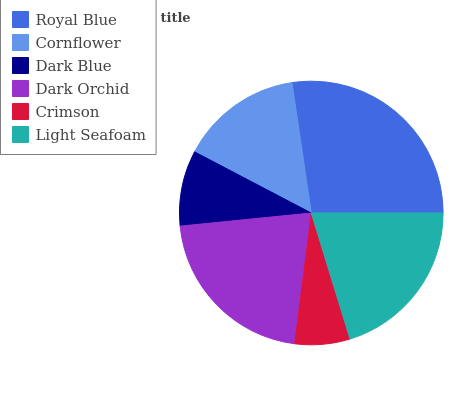Is Crimson the minimum?
Answer yes or no. Yes. Is Royal Blue the maximum?
Answer yes or no. Yes. Is Cornflower the minimum?
Answer yes or no. No. Is Cornflower the maximum?
Answer yes or no. No. Is Royal Blue greater than Cornflower?
Answer yes or no. Yes. Is Cornflower less than Royal Blue?
Answer yes or no. Yes. Is Cornflower greater than Royal Blue?
Answer yes or no. No. Is Royal Blue less than Cornflower?
Answer yes or no. No. Is Light Seafoam the high median?
Answer yes or no. Yes. Is Cornflower the low median?
Answer yes or no. Yes. Is Crimson the high median?
Answer yes or no. No. Is Dark Orchid the low median?
Answer yes or no. No. 